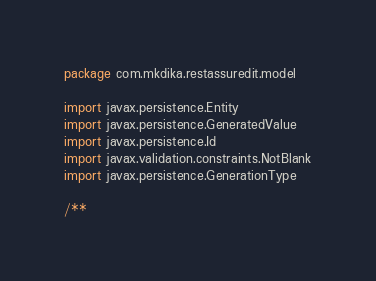<code> <loc_0><loc_0><loc_500><loc_500><_Kotlin_>package com.mkdika.restassuredit.model

import javax.persistence.Entity
import javax.persistence.GeneratedValue
import javax.persistence.Id
import javax.validation.constraints.NotBlank
import javax.persistence.GenerationType

/**</code> 